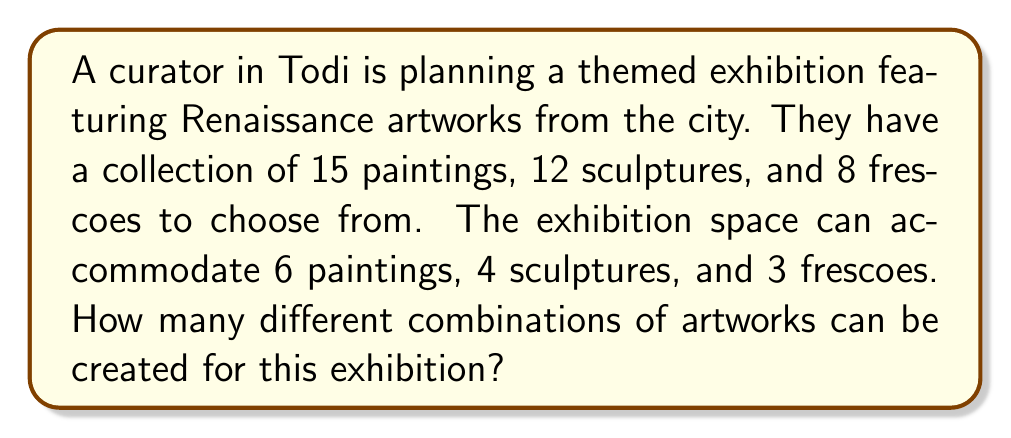Show me your answer to this math problem. To solve this problem, we need to use the combination formula for each type of artwork and then multiply the results together. The combination formula is:

$${n \choose k} = \frac{n!}{k!(n-k)!}$$

Where $n$ is the total number of items to choose from, and $k$ is the number of items being chosen.

1. For paintings: We need to choose 6 out of 15
   $$\text{Paintings} = {15 \choose 6} = \frac{15!}{6!(15-6)!} = \frac{15!}{6!9!} = 5005$$

2. For sculptures: We need to choose 4 out of 12
   $$\text{Sculptures} = {12 \choose 4} = \frac{12!}{4!(12-4)!} = \frac{12!}{4!8!} = 495$$

3. For frescoes: We need to choose 3 out of 8
   $$\text{Frescoes} = {8 \choose 3} = \frac{8!}{3!(8-3)!} = \frac{8!}{3!5!} = 56$$

Now, we multiply these results together to get the total number of possible combinations:

$$\text{Total combinations} = 5005 \times 495 \times 56 = 138,738,600$$

Therefore, there are 138,738,600 different ways to create the exhibition with the given constraints.
Answer: 138,738,600 